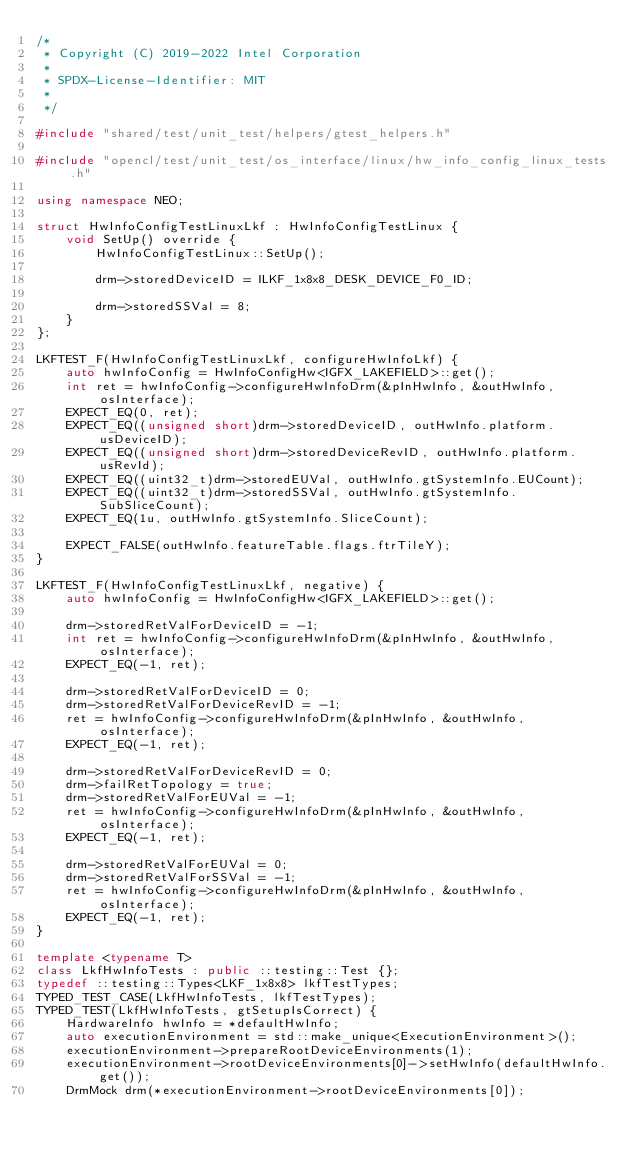Convert code to text. <code><loc_0><loc_0><loc_500><loc_500><_C++_>/*
 * Copyright (C) 2019-2022 Intel Corporation
 *
 * SPDX-License-Identifier: MIT
 *
 */

#include "shared/test/unit_test/helpers/gtest_helpers.h"

#include "opencl/test/unit_test/os_interface/linux/hw_info_config_linux_tests.h"

using namespace NEO;

struct HwInfoConfigTestLinuxLkf : HwInfoConfigTestLinux {
    void SetUp() override {
        HwInfoConfigTestLinux::SetUp();

        drm->storedDeviceID = ILKF_1x8x8_DESK_DEVICE_F0_ID;

        drm->storedSSVal = 8;
    }
};

LKFTEST_F(HwInfoConfigTestLinuxLkf, configureHwInfoLkf) {
    auto hwInfoConfig = HwInfoConfigHw<IGFX_LAKEFIELD>::get();
    int ret = hwInfoConfig->configureHwInfoDrm(&pInHwInfo, &outHwInfo, osInterface);
    EXPECT_EQ(0, ret);
    EXPECT_EQ((unsigned short)drm->storedDeviceID, outHwInfo.platform.usDeviceID);
    EXPECT_EQ((unsigned short)drm->storedDeviceRevID, outHwInfo.platform.usRevId);
    EXPECT_EQ((uint32_t)drm->storedEUVal, outHwInfo.gtSystemInfo.EUCount);
    EXPECT_EQ((uint32_t)drm->storedSSVal, outHwInfo.gtSystemInfo.SubSliceCount);
    EXPECT_EQ(1u, outHwInfo.gtSystemInfo.SliceCount);

    EXPECT_FALSE(outHwInfo.featureTable.flags.ftrTileY);
}

LKFTEST_F(HwInfoConfigTestLinuxLkf, negative) {
    auto hwInfoConfig = HwInfoConfigHw<IGFX_LAKEFIELD>::get();

    drm->storedRetValForDeviceID = -1;
    int ret = hwInfoConfig->configureHwInfoDrm(&pInHwInfo, &outHwInfo, osInterface);
    EXPECT_EQ(-1, ret);

    drm->storedRetValForDeviceID = 0;
    drm->storedRetValForDeviceRevID = -1;
    ret = hwInfoConfig->configureHwInfoDrm(&pInHwInfo, &outHwInfo, osInterface);
    EXPECT_EQ(-1, ret);

    drm->storedRetValForDeviceRevID = 0;
    drm->failRetTopology = true;
    drm->storedRetValForEUVal = -1;
    ret = hwInfoConfig->configureHwInfoDrm(&pInHwInfo, &outHwInfo, osInterface);
    EXPECT_EQ(-1, ret);

    drm->storedRetValForEUVal = 0;
    drm->storedRetValForSSVal = -1;
    ret = hwInfoConfig->configureHwInfoDrm(&pInHwInfo, &outHwInfo, osInterface);
    EXPECT_EQ(-1, ret);
}

template <typename T>
class LkfHwInfoTests : public ::testing::Test {};
typedef ::testing::Types<LKF_1x8x8> lkfTestTypes;
TYPED_TEST_CASE(LkfHwInfoTests, lkfTestTypes);
TYPED_TEST(LkfHwInfoTests, gtSetupIsCorrect) {
    HardwareInfo hwInfo = *defaultHwInfo;
    auto executionEnvironment = std::make_unique<ExecutionEnvironment>();
    executionEnvironment->prepareRootDeviceEnvironments(1);
    executionEnvironment->rootDeviceEnvironments[0]->setHwInfo(defaultHwInfo.get());
    DrmMock drm(*executionEnvironment->rootDeviceEnvironments[0]);</code> 